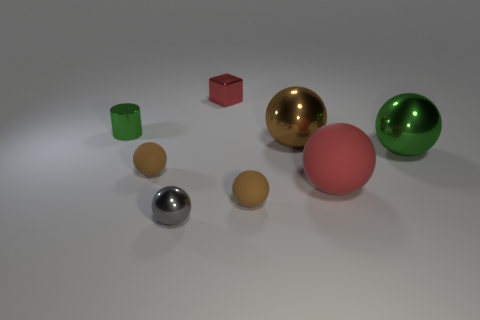Is there any other thing that is the same shape as the red metallic object?
Provide a short and direct response. No. Is the shape of the brown metal thing the same as the small gray metal object?
Provide a short and direct response. Yes. Is the number of tiny green things to the left of the tiny cylinder less than the number of big metal spheres that are to the right of the brown shiny ball?
Ensure brevity in your answer.  Yes. What number of red blocks are to the left of the big matte ball?
Your answer should be compact. 1. Do the red thing that is in front of the small green cylinder and the brown shiny object on the right side of the small shiny sphere have the same shape?
Offer a very short reply. Yes. How many other objects are the same color as the cylinder?
Give a very brief answer. 1. There is a green object that is to the right of the green cylinder left of the small metal object that is in front of the tiny cylinder; what is its material?
Give a very brief answer. Metal. What material is the big sphere in front of the green thing on the right side of the shiny cylinder made of?
Ensure brevity in your answer.  Rubber. Is the number of big metallic things to the right of the red matte thing less than the number of green metal things?
Make the answer very short. Yes. What is the shape of the object on the right side of the big red rubber object?
Your response must be concise. Sphere. 